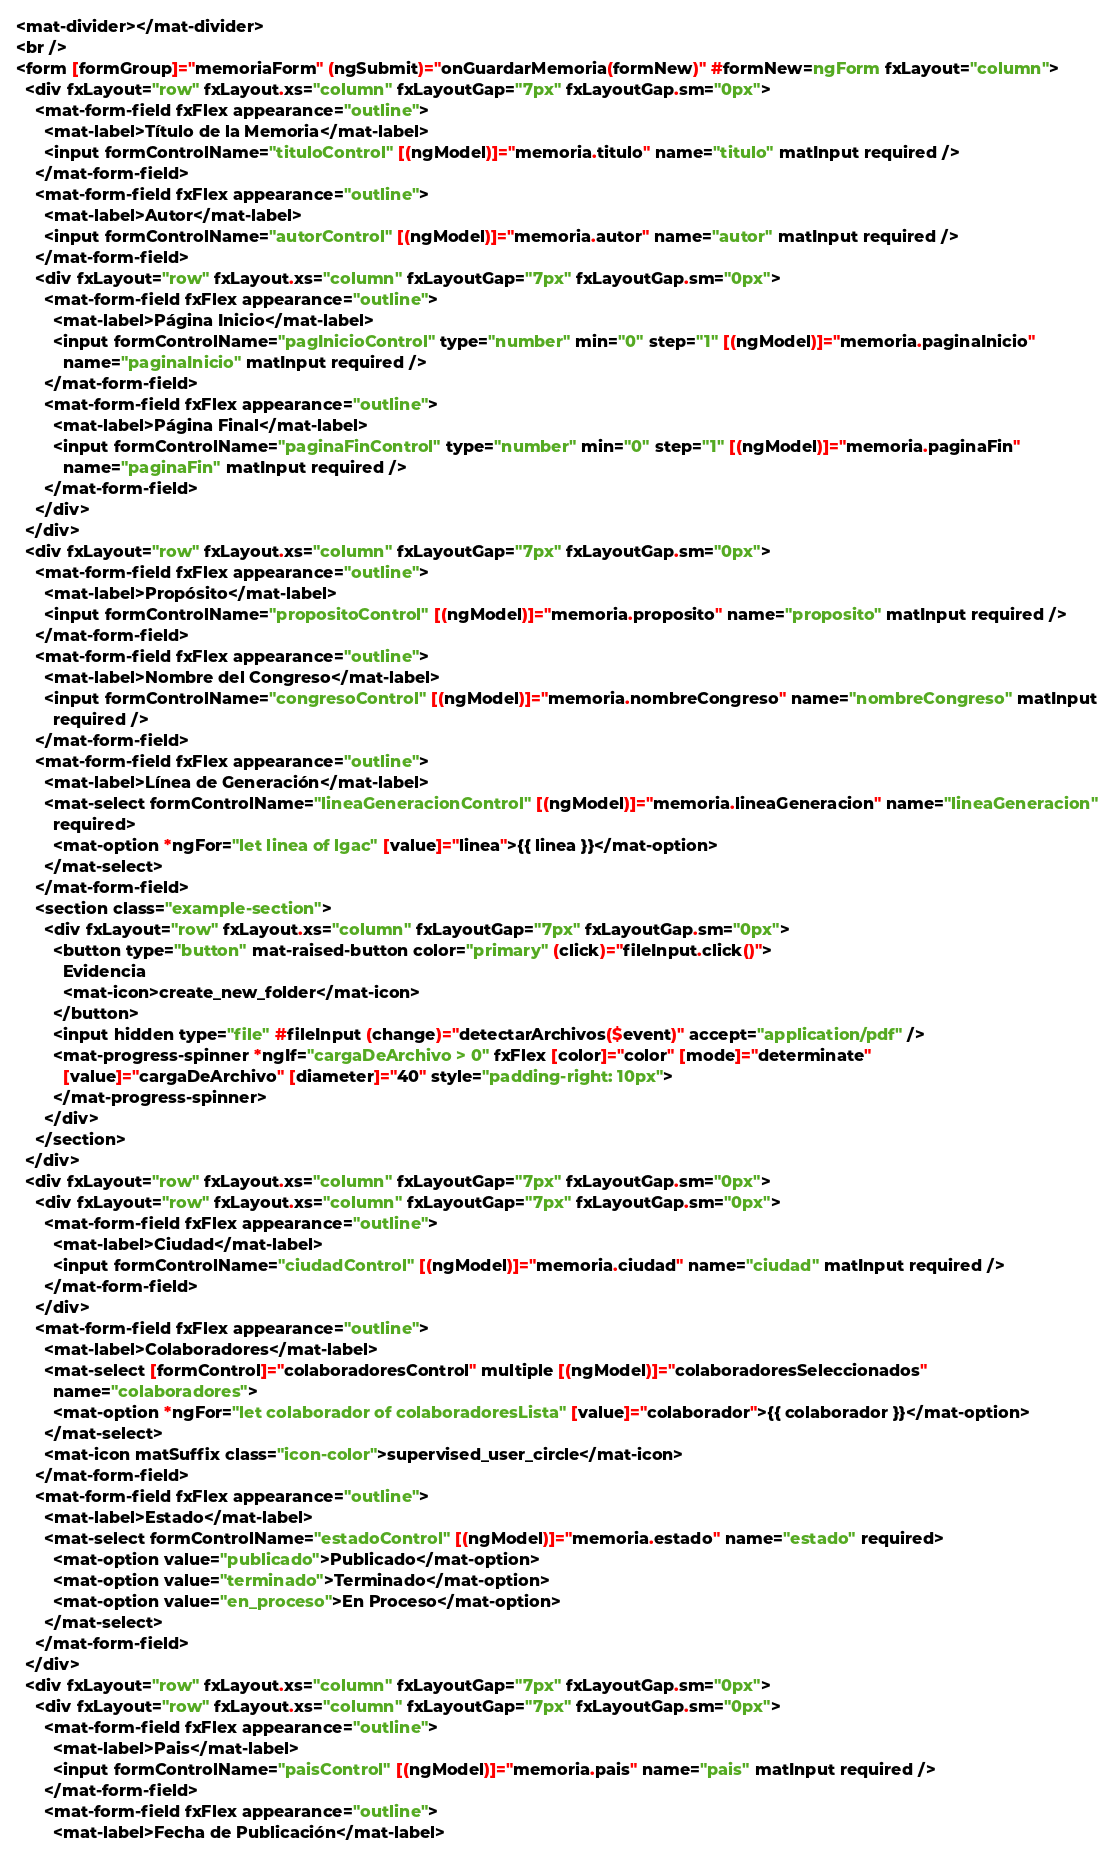Convert code to text. <code><loc_0><loc_0><loc_500><loc_500><_HTML_><mat-divider></mat-divider>
<br />
<form [formGroup]="memoriaForm" (ngSubmit)="onGuardarMemoria(formNew)" #formNew=ngForm fxLayout="column">
  <div fxLayout="row" fxLayout.xs="column" fxLayoutGap="7px" fxLayoutGap.sm="0px">
    <mat-form-field fxFlex appearance="outline">
      <mat-label>Título de la Memoria</mat-label>
      <input formControlName="tituloControl" [(ngModel)]="memoria.titulo" name="titulo" matInput required />
    </mat-form-field>
    <mat-form-field fxFlex appearance="outline">
      <mat-label>Autor</mat-label>
      <input formControlName="autorControl" [(ngModel)]="memoria.autor" name="autor" matInput required />
    </mat-form-field>
    <div fxLayout="row" fxLayout.xs="column" fxLayoutGap="7px" fxLayoutGap.sm="0px">
      <mat-form-field fxFlex appearance="outline">
        <mat-label>Página Inicio</mat-label>
        <input formControlName="pagInicioControl" type="number" min="0" step="1" [(ngModel)]="memoria.paginaInicio"
          name="paginaInicio" matInput required />
      </mat-form-field>
      <mat-form-field fxFlex appearance="outline">
        <mat-label>Página Final</mat-label>
        <input formControlName="paginaFinControl" type="number" min="0" step="1" [(ngModel)]="memoria.paginaFin"
          name="paginaFin" matInput required />
      </mat-form-field>
    </div>
  </div>
  <div fxLayout="row" fxLayout.xs="column" fxLayoutGap="7px" fxLayoutGap.sm="0px">
    <mat-form-field fxFlex appearance="outline">
      <mat-label>Propósito</mat-label>
      <input formControlName="propositoControl" [(ngModel)]="memoria.proposito" name="proposito" matInput required />
    </mat-form-field>
    <mat-form-field fxFlex appearance="outline">
      <mat-label>Nombre del Congreso</mat-label>
      <input formControlName="congresoControl" [(ngModel)]="memoria.nombreCongreso" name="nombreCongreso" matInput
        required />
    </mat-form-field>
    <mat-form-field fxFlex appearance="outline">
      <mat-label>Línea de Generación</mat-label>
      <mat-select formControlName="lineaGeneracionControl" [(ngModel)]="memoria.lineaGeneracion" name="lineaGeneracion"
        required>
        <mat-option *ngFor="let linea of lgac" [value]="linea">{{ linea }}</mat-option>
      </mat-select>
    </mat-form-field>
    <section class="example-section">
      <div fxLayout="row" fxLayout.xs="column" fxLayoutGap="7px" fxLayoutGap.sm="0px">
        <button type="button" mat-raised-button color="primary" (click)="fileInput.click()">
          Evidencia
          <mat-icon>create_new_folder</mat-icon>
        </button>
        <input hidden type="file" #fileInput (change)="detectarArchivos($event)" accept="application/pdf" />
        <mat-progress-spinner *ngIf="cargaDeArchivo > 0" fxFlex [color]="color" [mode]="determinate"
          [value]="cargaDeArchivo" [diameter]="40" style="padding-right: 10px">
        </mat-progress-spinner>
      </div>
    </section>
  </div>
  <div fxLayout="row" fxLayout.xs="column" fxLayoutGap="7px" fxLayoutGap.sm="0px">
    <div fxLayout="row" fxLayout.xs="column" fxLayoutGap="7px" fxLayoutGap.sm="0px">
      <mat-form-field fxFlex appearance="outline">
        <mat-label>Ciudad</mat-label>
        <input formControlName="ciudadControl" [(ngModel)]="memoria.ciudad" name="ciudad" matInput required />
      </mat-form-field>
    </div>
    <mat-form-field fxFlex appearance="outline">
      <mat-label>Colaboradores</mat-label>
      <mat-select [formControl]="colaboradoresControl" multiple [(ngModel)]="colaboradoresSeleccionados"
        name="colaboradores">
        <mat-option *ngFor="let colaborador of colaboradoresLista" [value]="colaborador">{{ colaborador }}</mat-option>
      </mat-select>
      <mat-icon matSuffix class="icon-color">supervised_user_circle</mat-icon>
    </mat-form-field>
    <mat-form-field fxFlex appearance="outline">
      <mat-label>Estado</mat-label>
      <mat-select formControlName="estadoControl" [(ngModel)]="memoria.estado" name="estado" required>
        <mat-option value="publicado">Publicado</mat-option>
        <mat-option value="terminado">Terminado</mat-option>
        <mat-option value="en_proceso">En Proceso</mat-option>
      </mat-select>
    </mat-form-field>
  </div>
  <div fxLayout="row" fxLayout.xs="column" fxLayoutGap="7px" fxLayoutGap.sm="0px">
    <div fxLayout="row" fxLayout.xs="column" fxLayoutGap="7px" fxLayoutGap.sm="0px">
      <mat-form-field fxFlex appearance="outline">
        <mat-label>Pais</mat-label>
        <input formControlName="paisControl" [(ngModel)]="memoria.pais" name="pais" matInput required />
      </mat-form-field>
      <mat-form-field fxFlex appearance="outline">
        <mat-label>Fecha de Publicación</mat-label></code> 